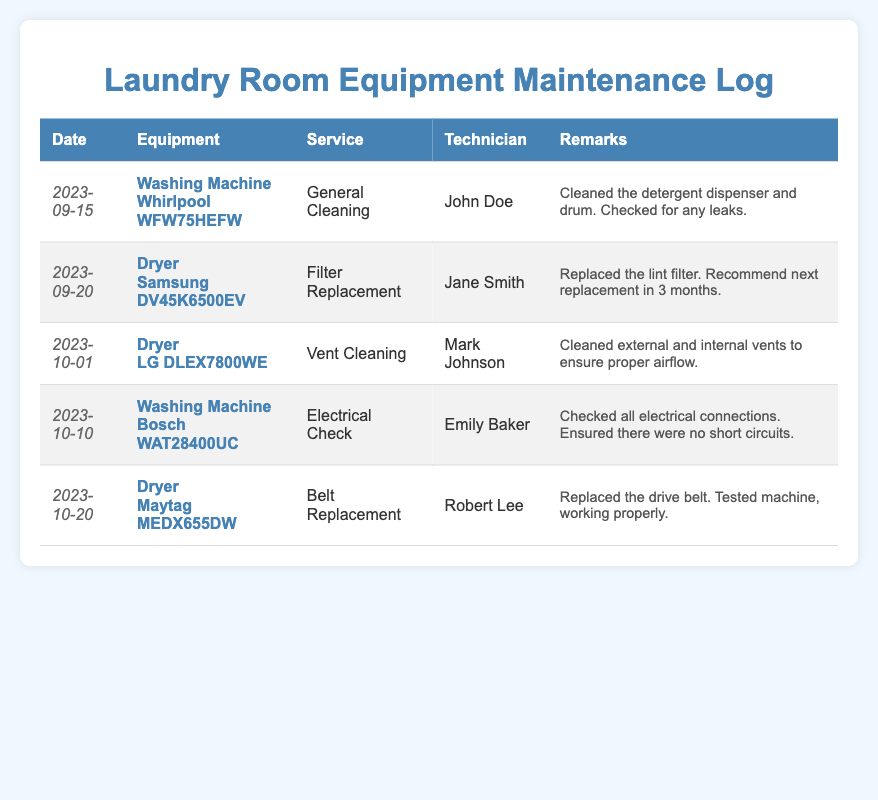What is the date of the last maintenance performed? The last maintenance listed in the document took place on October 20, 2023.
Answer: October 20, 2023 Who serviced the Washing Machine on September 15, 2023? The technician who serviced the Washing Machine was John Doe.
Answer: John Doe What type of service was performed on the Dryer on October 1, 2023? The service performed on the Dryer on October 1, 2023, was Vent Cleaning.
Answer: Vent Cleaning Which Dryer had a filter replacement on September 20, 2023? The Dryer that had a filter replacement is the Samsung DV45K6500EV.
Answer: Samsung DV45K6500EV What was the technician's name who conducted the electrical check? The electrical check was conducted by Emily Baker.
Answer: Emily Baker How many types of services were documented for the Dryer? There are three types of services documented for the Dryer: Filter Replacement, Vent Cleaning, and Belt Replacement.
Answer: Three Which equipment had its drive belt replaced? The equipment that had its drive belt replaced is the Maytag MEDX655DW.
Answer: Maytag MEDX655DW What recommendation was given after the filter replacement service? The recommendation was to replace the lint filter in 3 months.
Answer: Next replacement in 3 months 